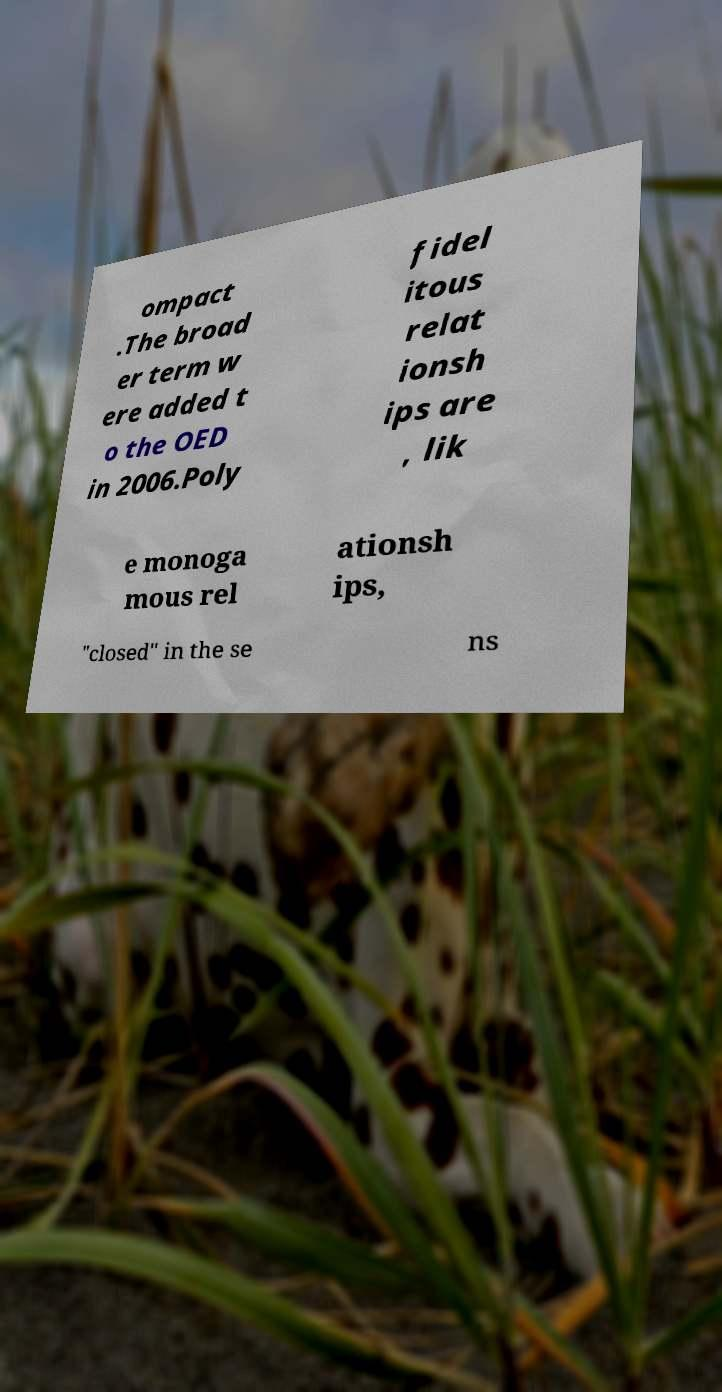Could you extract and type out the text from this image? ompact .The broad er term w ere added t o the OED in 2006.Poly fidel itous relat ionsh ips are , lik e monoga mous rel ationsh ips, "closed" in the se ns 